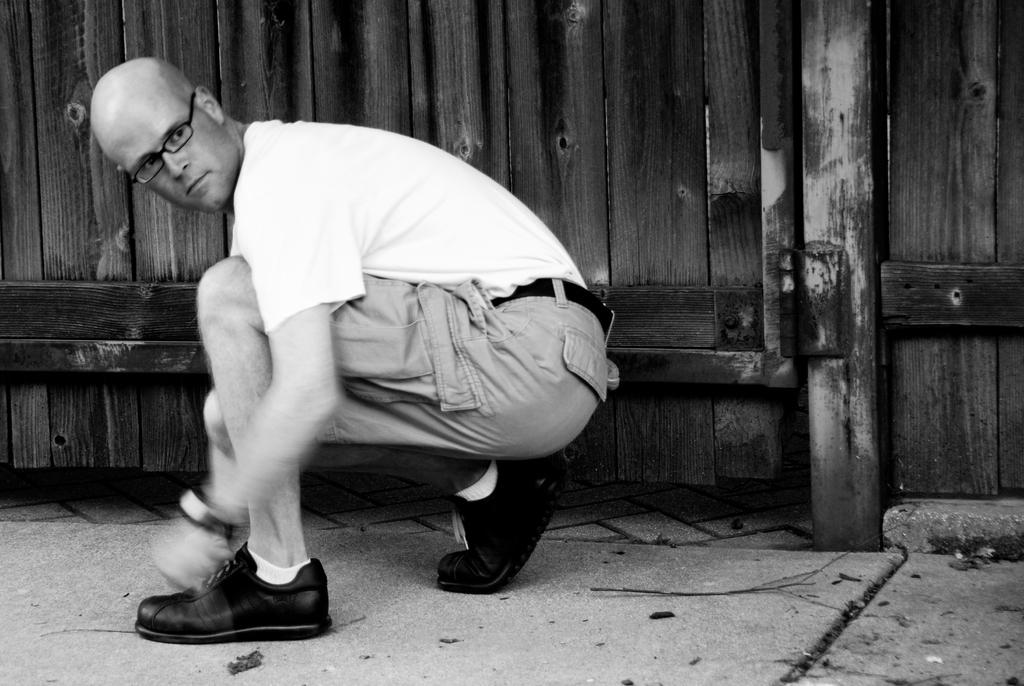What is present in the image? There is a person in the image. Can you describe any objects in the background of the image? There is a wooden object in the background of the image. What color scheme is used in the image? The image is in black and white. Is there a letter being written in the image? There is no indication of a letter or writing in the image. Is the person in the image asking for help? There is no indication of the person needing help or asking for it in the image. 